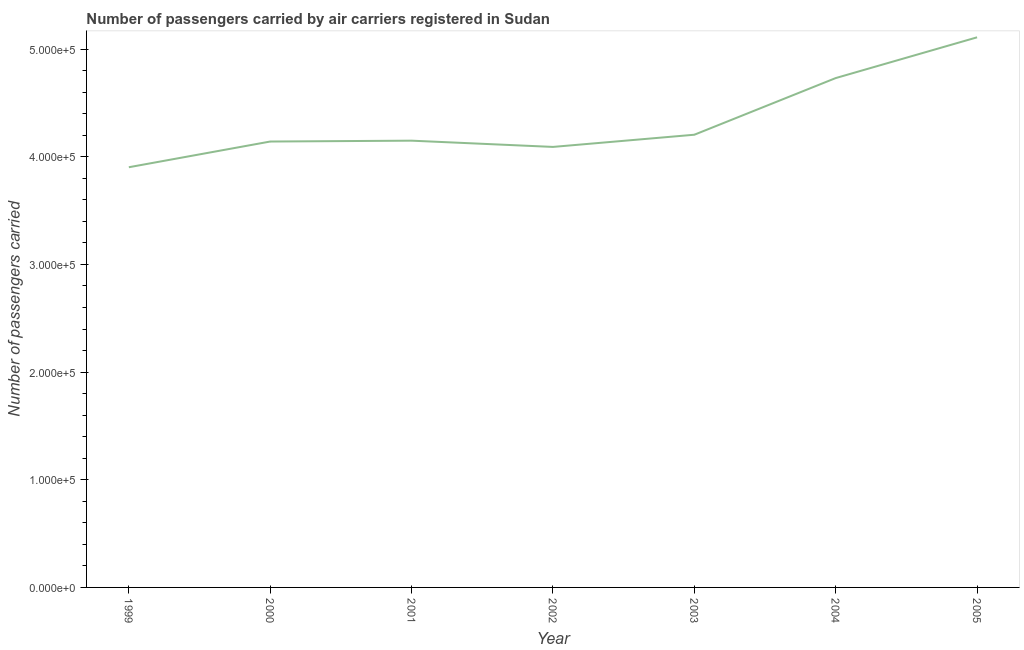What is the number of passengers carried in 2005?
Your answer should be very brief. 5.11e+05. Across all years, what is the maximum number of passengers carried?
Your answer should be very brief. 5.11e+05. Across all years, what is the minimum number of passengers carried?
Provide a succinct answer. 3.90e+05. In which year was the number of passengers carried maximum?
Offer a very short reply. 2005. In which year was the number of passengers carried minimum?
Ensure brevity in your answer.  1999. What is the sum of the number of passengers carried?
Give a very brief answer. 3.03e+06. What is the difference between the number of passengers carried in 1999 and 2005?
Keep it short and to the point. -1.21e+05. What is the average number of passengers carried per year?
Your answer should be compact. 4.33e+05. What is the median number of passengers carried?
Ensure brevity in your answer.  4.15e+05. Do a majority of the years between 2000 and 2002 (inclusive) have number of passengers carried greater than 20000 ?
Give a very brief answer. Yes. What is the ratio of the number of passengers carried in 2001 to that in 2005?
Provide a short and direct response. 0.81. What is the difference between the highest and the second highest number of passengers carried?
Your answer should be very brief. 3.78e+04. What is the difference between the highest and the lowest number of passengers carried?
Make the answer very short. 1.21e+05. What is the difference between two consecutive major ticks on the Y-axis?
Offer a very short reply. 1.00e+05. Does the graph contain any zero values?
Your response must be concise. No. What is the title of the graph?
Your answer should be compact. Number of passengers carried by air carriers registered in Sudan. What is the label or title of the X-axis?
Offer a terse response. Year. What is the label or title of the Y-axis?
Provide a succinct answer. Number of passengers carried. What is the Number of passengers carried in 1999?
Your answer should be compact. 3.90e+05. What is the Number of passengers carried of 2000?
Keep it short and to the point. 4.14e+05. What is the Number of passengers carried of 2001?
Give a very brief answer. 4.15e+05. What is the Number of passengers carried of 2002?
Keep it short and to the point. 4.09e+05. What is the Number of passengers carried of 2003?
Give a very brief answer. 4.20e+05. What is the Number of passengers carried in 2004?
Your response must be concise. 4.73e+05. What is the Number of passengers carried of 2005?
Offer a terse response. 5.11e+05. What is the difference between the Number of passengers carried in 1999 and 2000?
Provide a succinct answer. -2.39e+04. What is the difference between the Number of passengers carried in 1999 and 2001?
Ensure brevity in your answer.  -2.47e+04. What is the difference between the Number of passengers carried in 1999 and 2002?
Provide a short and direct response. -1.89e+04. What is the difference between the Number of passengers carried in 1999 and 2003?
Your answer should be compact. -3.02e+04. What is the difference between the Number of passengers carried in 1999 and 2004?
Make the answer very short. -8.28e+04. What is the difference between the Number of passengers carried in 1999 and 2005?
Your answer should be very brief. -1.21e+05. What is the difference between the Number of passengers carried in 2000 and 2001?
Ensure brevity in your answer.  -804. What is the difference between the Number of passengers carried in 2000 and 2002?
Your answer should be very brief. 5001. What is the difference between the Number of passengers carried in 2000 and 2003?
Provide a succinct answer. -6319. What is the difference between the Number of passengers carried in 2000 and 2004?
Your answer should be very brief. -5.89e+04. What is the difference between the Number of passengers carried in 2000 and 2005?
Offer a terse response. -9.68e+04. What is the difference between the Number of passengers carried in 2001 and 2002?
Offer a terse response. 5805. What is the difference between the Number of passengers carried in 2001 and 2003?
Offer a terse response. -5515. What is the difference between the Number of passengers carried in 2001 and 2004?
Your answer should be very brief. -5.81e+04. What is the difference between the Number of passengers carried in 2001 and 2005?
Give a very brief answer. -9.60e+04. What is the difference between the Number of passengers carried in 2002 and 2003?
Keep it short and to the point. -1.13e+04. What is the difference between the Number of passengers carried in 2002 and 2004?
Make the answer very short. -6.39e+04. What is the difference between the Number of passengers carried in 2002 and 2005?
Keep it short and to the point. -1.02e+05. What is the difference between the Number of passengers carried in 2003 and 2004?
Provide a succinct answer. -5.26e+04. What is the difference between the Number of passengers carried in 2003 and 2005?
Your response must be concise. -9.05e+04. What is the difference between the Number of passengers carried in 2004 and 2005?
Provide a short and direct response. -3.78e+04. What is the ratio of the Number of passengers carried in 1999 to that in 2000?
Provide a succinct answer. 0.94. What is the ratio of the Number of passengers carried in 1999 to that in 2001?
Keep it short and to the point. 0.94. What is the ratio of the Number of passengers carried in 1999 to that in 2002?
Your answer should be compact. 0.95. What is the ratio of the Number of passengers carried in 1999 to that in 2003?
Your answer should be compact. 0.93. What is the ratio of the Number of passengers carried in 1999 to that in 2004?
Provide a short and direct response. 0.82. What is the ratio of the Number of passengers carried in 1999 to that in 2005?
Keep it short and to the point. 0.76. What is the ratio of the Number of passengers carried in 2000 to that in 2003?
Offer a very short reply. 0.98. What is the ratio of the Number of passengers carried in 2000 to that in 2005?
Offer a terse response. 0.81. What is the ratio of the Number of passengers carried in 2001 to that in 2002?
Ensure brevity in your answer.  1.01. What is the ratio of the Number of passengers carried in 2001 to that in 2003?
Provide a short and direct response. 0.99. What is the ratio of the Number of passengers carried in 2001 to that in 2004?
Give a very brief answer. 0.88. What is the ratio of the Number of passengers carried in 2001 to that in 2005?
Make the answer very short. 0.81. What is the ratio of the Number of passengers carried in 2002 to that in 2003?
Give a very brief answer. 0.97. What is the ratio of the Number of passengers carried in 2002 to that in 2004?
Your response must be concise. 0.86. What is the ratio of the Number of passengers carried in 2002 to that in 2005?
Offer a very short reply. 0.8. What is the ratio of the Number of passengers carried in 2003 to that in 2004?
Make the answer very short. 0.89. What is the ratio of the Number of passengers carried in 2003 to that in 2005?
Make the answer very short. 0.82. What is the ratio of the Number of passengers carried in 2004 to that in 2005?
Your answer should be very brief. 0.93. 